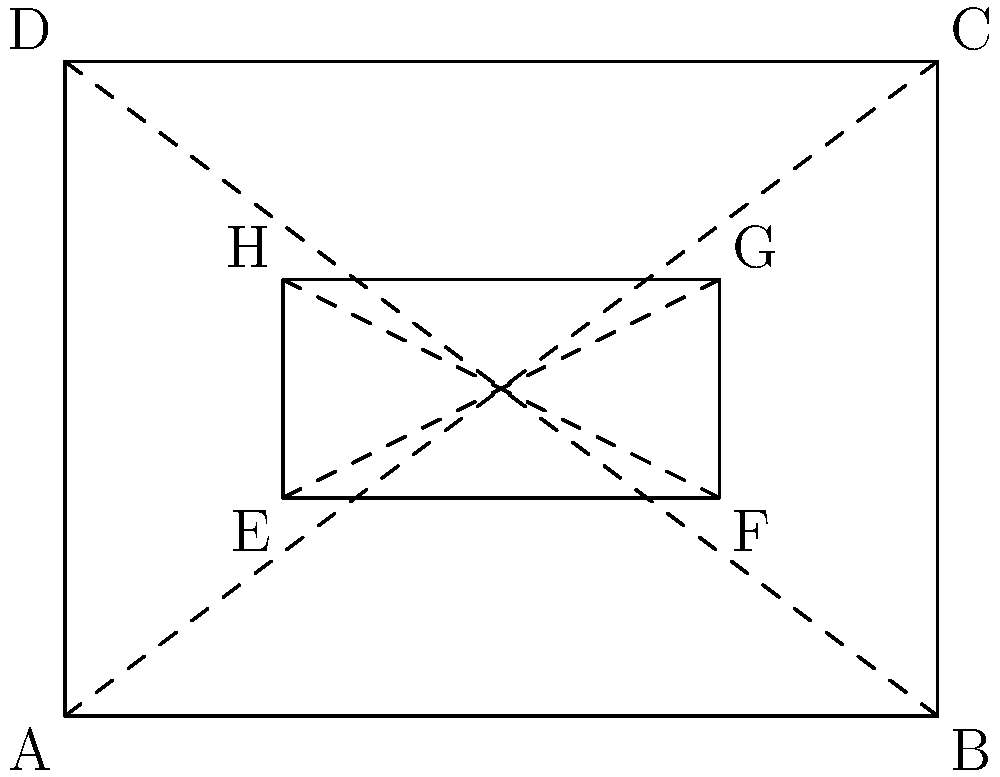In designing a bracelet for a youth empowerment program, you've created a rectangular shape with a smaller rectangle inside, as shown in the diagram. If $\overline{AB} \cong \overline{DC}$ and $\overline{EF} \cong \overline{HG}$, what other pair of segments can you conclude are congruent based on the properties of rectangles? To solve this problem, let's follow these steps:

1. Recall that in a rectangle, opposite sides are congruent and parallel.

2. We're given that $\overline{AB} \cong \overline{DC}$ and $\overline{EF} \cong \overline{HG}$, which are pairs of opposite sides in the outer and inner rectangles respectively.

3. In the outer rectangle ABCD:
   - $\overline{AB} \cong \overline{DC}$ (given)
   - Therefore, $\overline{AD} \cong \overline{BC}$ (opposite sides of a rectangle)

4. In the inner rectangle EFGH:
   - $\overline{EF} \cong \overline{HG}$ (given)
   - Therefore, $\overline{EH} \cong \overline{FG}$ (opposite sides of a rectangle)

5. The diagonals of a rectangle bisect each other. This means:
   - $\overline{AC}$ and $\overline{BD}$ bisect each other in the outer rectangle
   - $\overline{EG}$ and $\overline{FH}$ bisect each other in the inner rectangle

6. Given all these properties, we can conclude that $\overline{AD} \cong \overline{BC}$ is another pair of congruent segments based on the properties of rectangles.
Answer: $\overline{AD} \cong \overline{BC}$ 